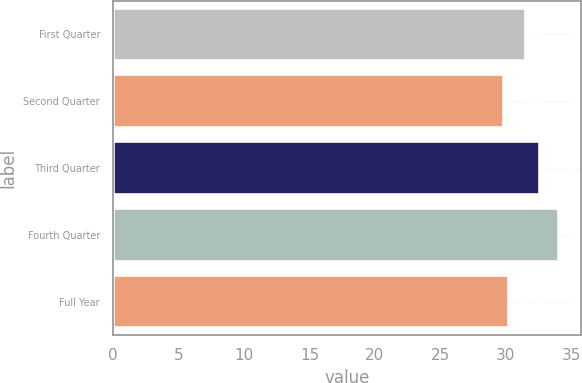Convert chart. <chart><loc_0><loc_0><loc_500><loc_500><bar_chart><fcel>First Quarter<fcel>Second Quarter<fcel>Third Quarter<fcel>Fourth Quarter<fcel>Full Year<nl><fcel>31.59<fcel>29.85<fcel>32.61<fcel>34.06<fcel>30.27<nl></chart> 